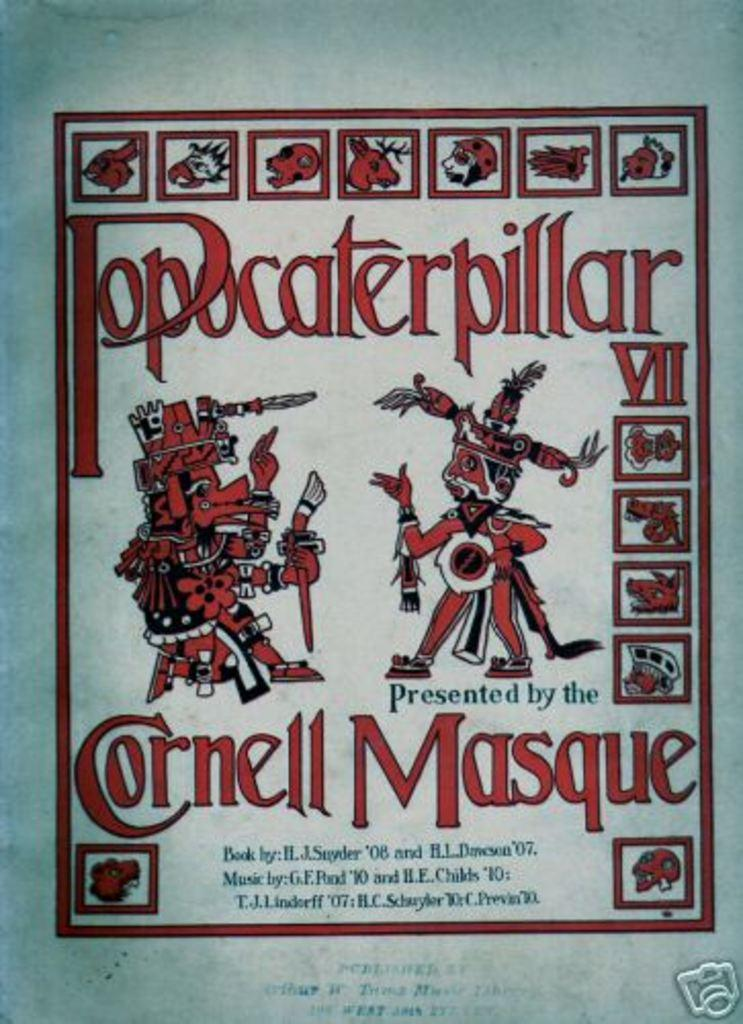Provide a one-sentence caption for the provided image. a red painting with the word Cornell under it. 